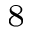Convert formula to latex. <formula><loc_0><loc_0><loc_500><loc_500>^ { 8 }</formula> 